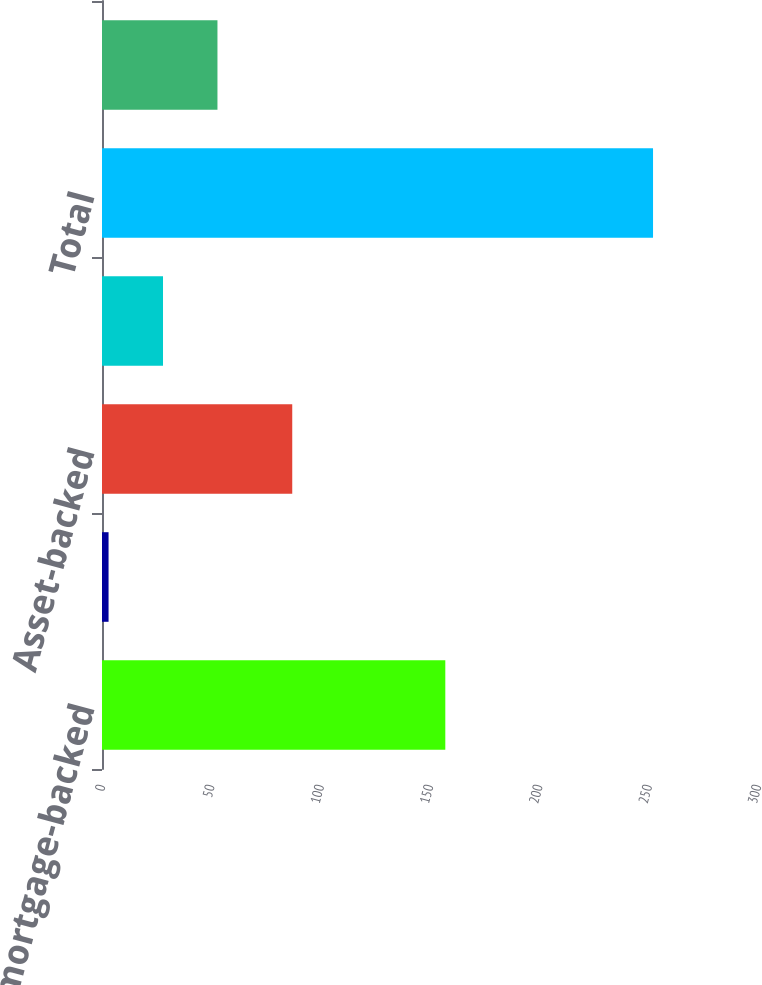<chart> <loc_0><loc_0><loc_500><loc_500><bar_chart><fcel>Residential mortgage-backed<fcel>Commercial mortgage-backed<fcel>Asset-backed<fcel>State and municipal<fcel>Total<fcel>Total debt securities<nl><fcel>157<fcel>3<fcel>87<fcel>27.9<fcel>252<fcel>52.8<nl></chart> 